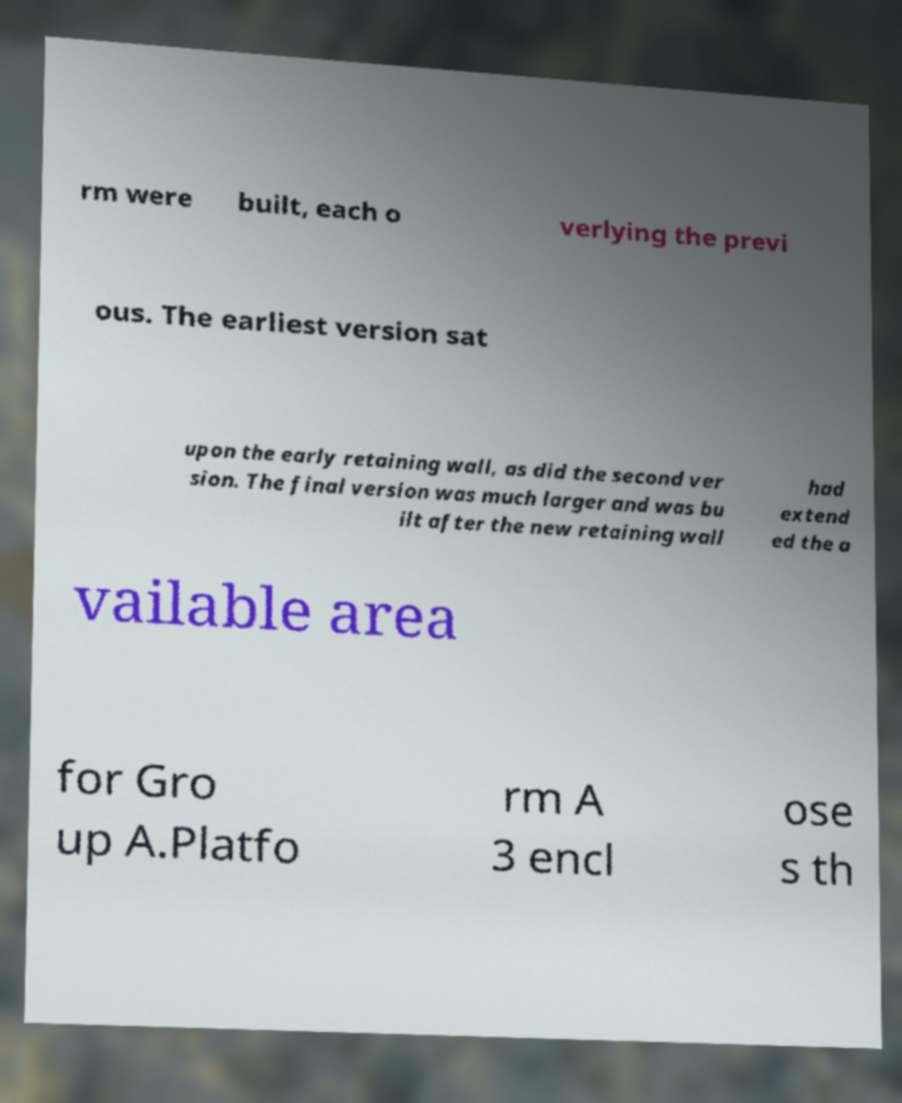Could you extract and type out the text from this image? rm were built, each o verlying the previ ous. The earliest version sat upon the early retaining wall, as did the second ver sion. The final version was much larger and was bu ilt after the new retaining wall had extend ed the a vailable area for Gro up A.Platfo rm A 3 encl ose s th 